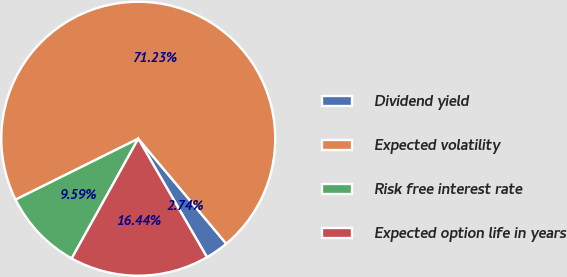Convert chart. <chart><loc_0><loc_0><loc_500><loc_500><pie_chart><fcel>Dividend yield<fcel>Expected volatility<fcel>Risk free interest rate<fcel>Expected option life in years<nl><fcel>2.74%<fcel>71.23%<fcel>9.59%<fcel>16.44%<nl></chart> 